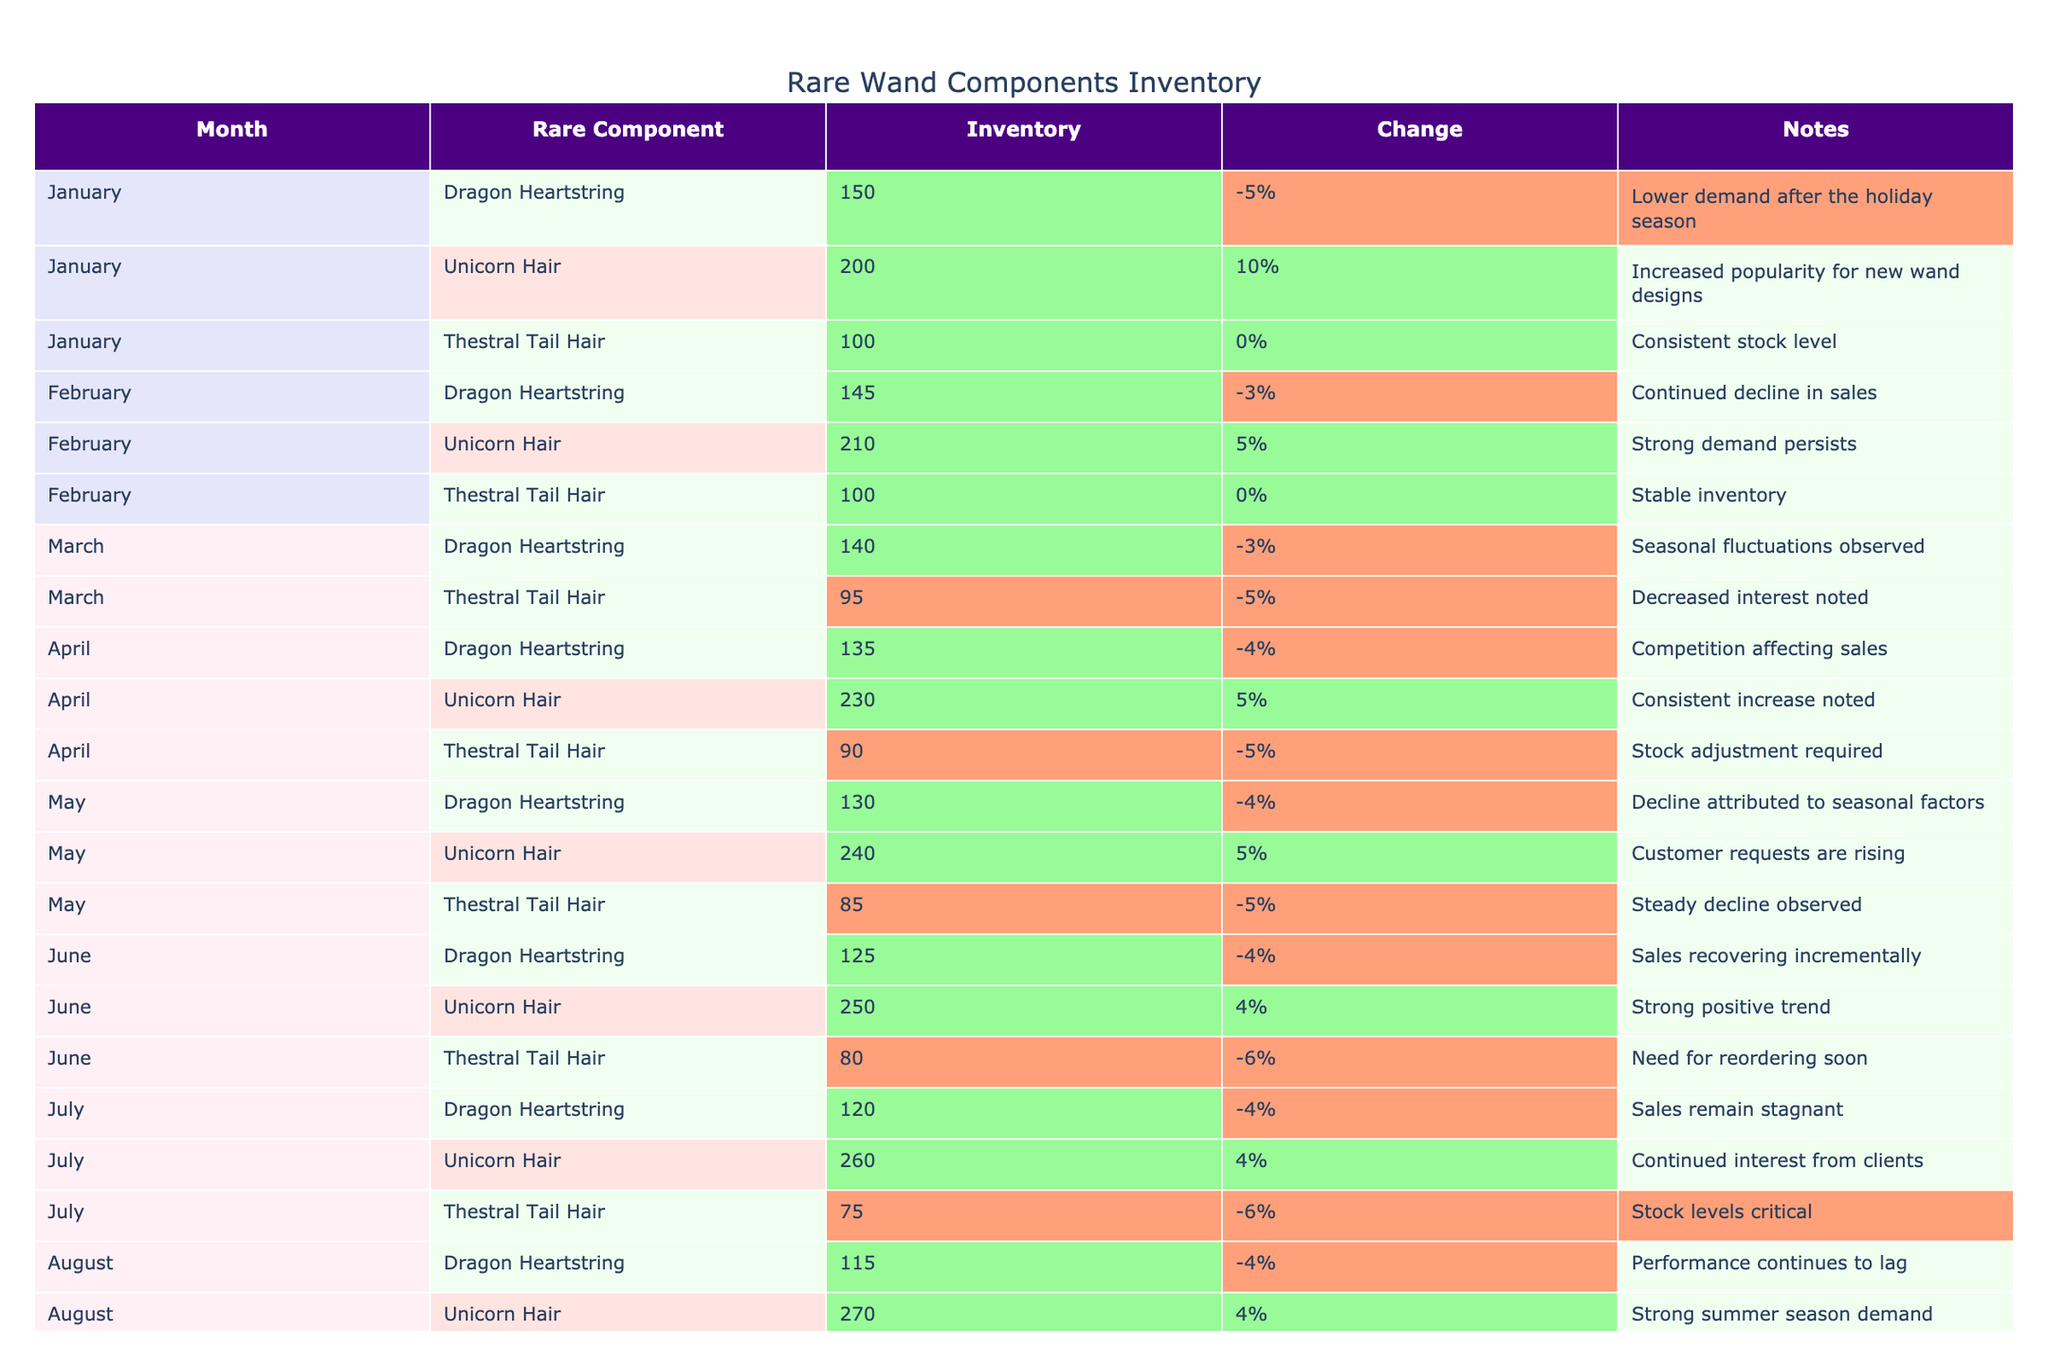What was the inventory level of Unicorn Hair in December? The table indicates that the inventory level of Unicorn Hair in December is 310 units.
Answer: 310 How many units of Thestral Tail Hair were in stock in February? According to the table, the inventory level of Thestral Tail Hair in February remains stable at 100 units.
Answer: 100 Which rare component experienced the largest decrease in inventory from January to April? Dragon Heartstring starts at 150 units in January and declines to 135 units by April, which is a decrease of 15 units. Unicorn Hair increases instead, and Thestral Tail Hair also decreases but not as much as Dragon Heartstring.
Answer: Dragon Heartstring What was the total decrease in inventory for Dragon Heartstring from January to March? The inventory levels for Dragon Heartstring are 150 (January), 145 (February), and 140 (March). The total decrease is (150 - 140) = 10 units.
Answer: 10 Was there a month when Unicorn Hair didn't increase in inventory levels? Reviewing the table, Unicorn Hair consistently increased in inventory levels each month from January to December. Therefore, there was no month when its inventory decreased or stayed the same.
Answer: No What month showed the most significant drop in the inventory level of Thestral Tail Hair? By examining the table, Thestral Tail Hair inventory shows a drop from 100 in January to 60 in October and then to 50 in December, totaling a decrease of 50 units from January to December. However, the most significant drop occurs between November and December when it decreases by 5 units from 55 to 50.
Answer: November to December What was the average inventory level of Dragon Heartstring for the year? The inventory levels for Dragon Heartstring are 150, 145, 140, 135, 130, 125, 120, 115, 110, 105, 100, and 95. Summing these gives 1,480, and dividing by 12 months provides an average of approximately 123.33.
Answer: Approximately 123.33 Which month had the highest inventory level overall across all components? Looking at the table, the highest inventory level is for Unicorn Hair in December at 310 units, which is higher than any other component in any month.
Answer: December What percentage change did Unicorn Hair experience in November compared to October? Unicorn Hair had 290 units in October and increased to 300 in November. The percentage change is calculated as ((300 - 290) / 290) * 100 = 3.45%.
Answer: Approximately 3.45% What is the total number of units in stock for all three components in the month of September? The inventory levels for September are Dragon Heartstring at 110, Unicorn Hair at 280, and Thestral Tail Hair at 65. Adding these together gives 110 + 280 + 65 = 455 units.
Answer: 455 How many months saw a decrease in inventory for Thestral Tail Hair? In the table, Thestral Tail Hair shows a decline every month after January, specifically from 100 in January to 50 in December. This is a total of 11 months with decreasing inventory levels.
Answer: 11 months 